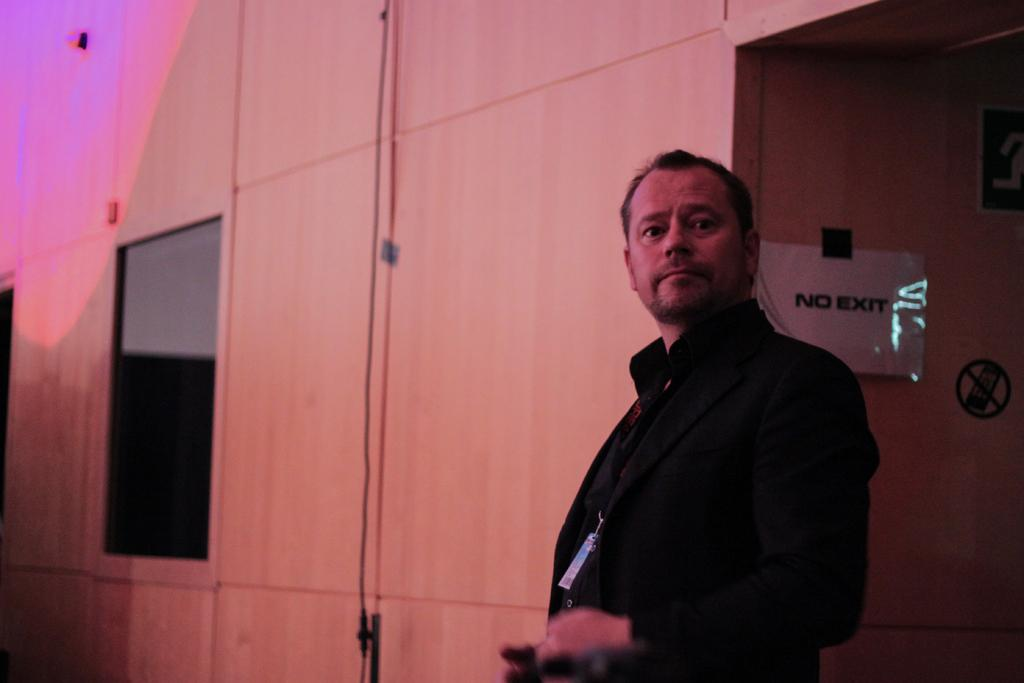What is the main subject in the image? There is a person standing in the image. What can be seen behind the person? There is a wall behind the person. Is there anything attached to the wall? Yes, there is a paper attached to the wall. What type of polish is the person applying to the wall in the image? There is no polish or any indication of polishing in the image. How many giants are visible in the image? There are no giants present in the image. 